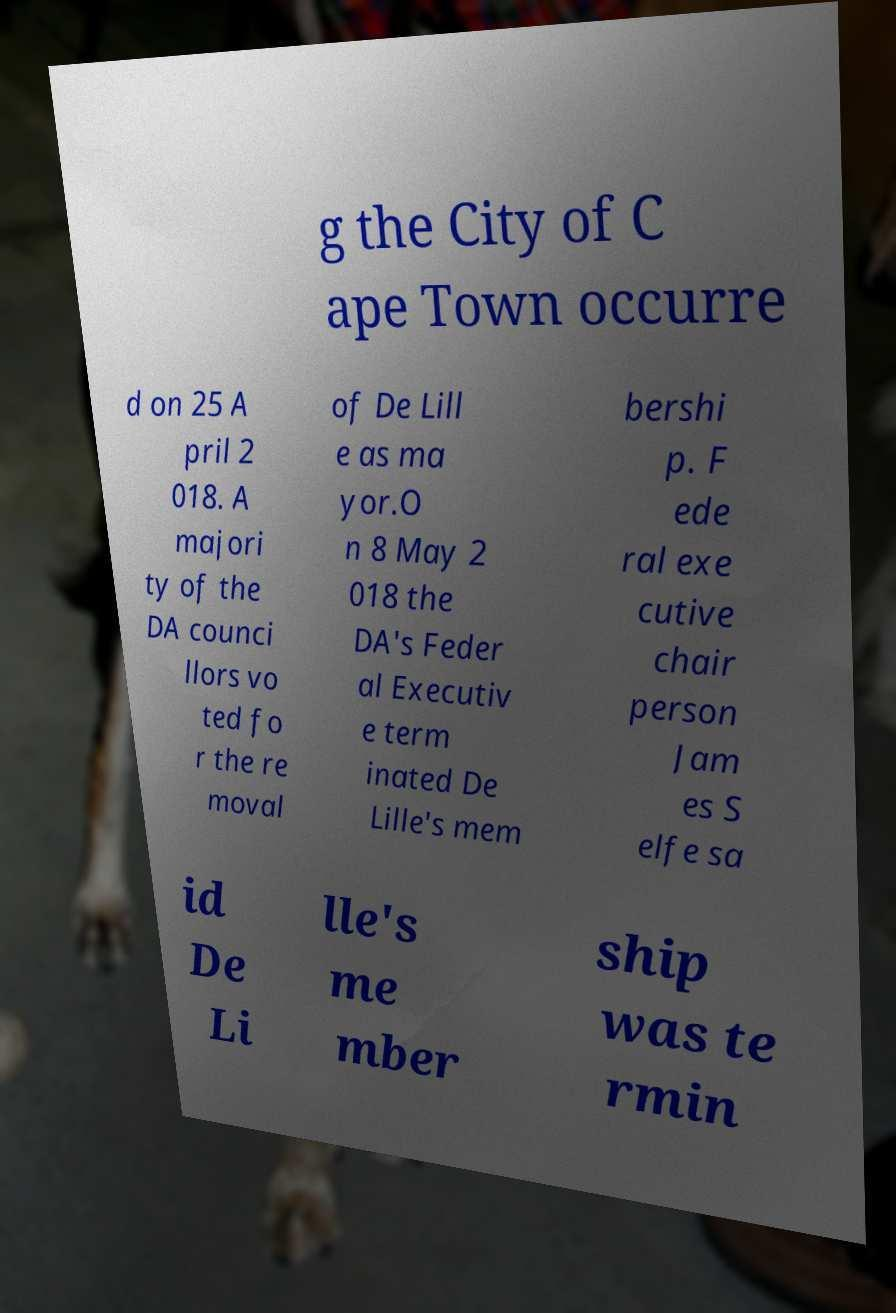Can you read and provide the text displayed in the image?This photo seems to have some interesting text. Can you extract and type it out for me? g the City of C ape Town occurre d on 25 A pril 2 018. A majori ty of the DA counci llors vo ted fo r the re moval of De Lill e as ma yor.O n 8 May 2 018 the DA's Feder al Executiv e term inated De Lille's mem bershi p. F ede ral exe cutive chair person Jam es S elfe sa id De Li lle's me mber ship was te rmin 